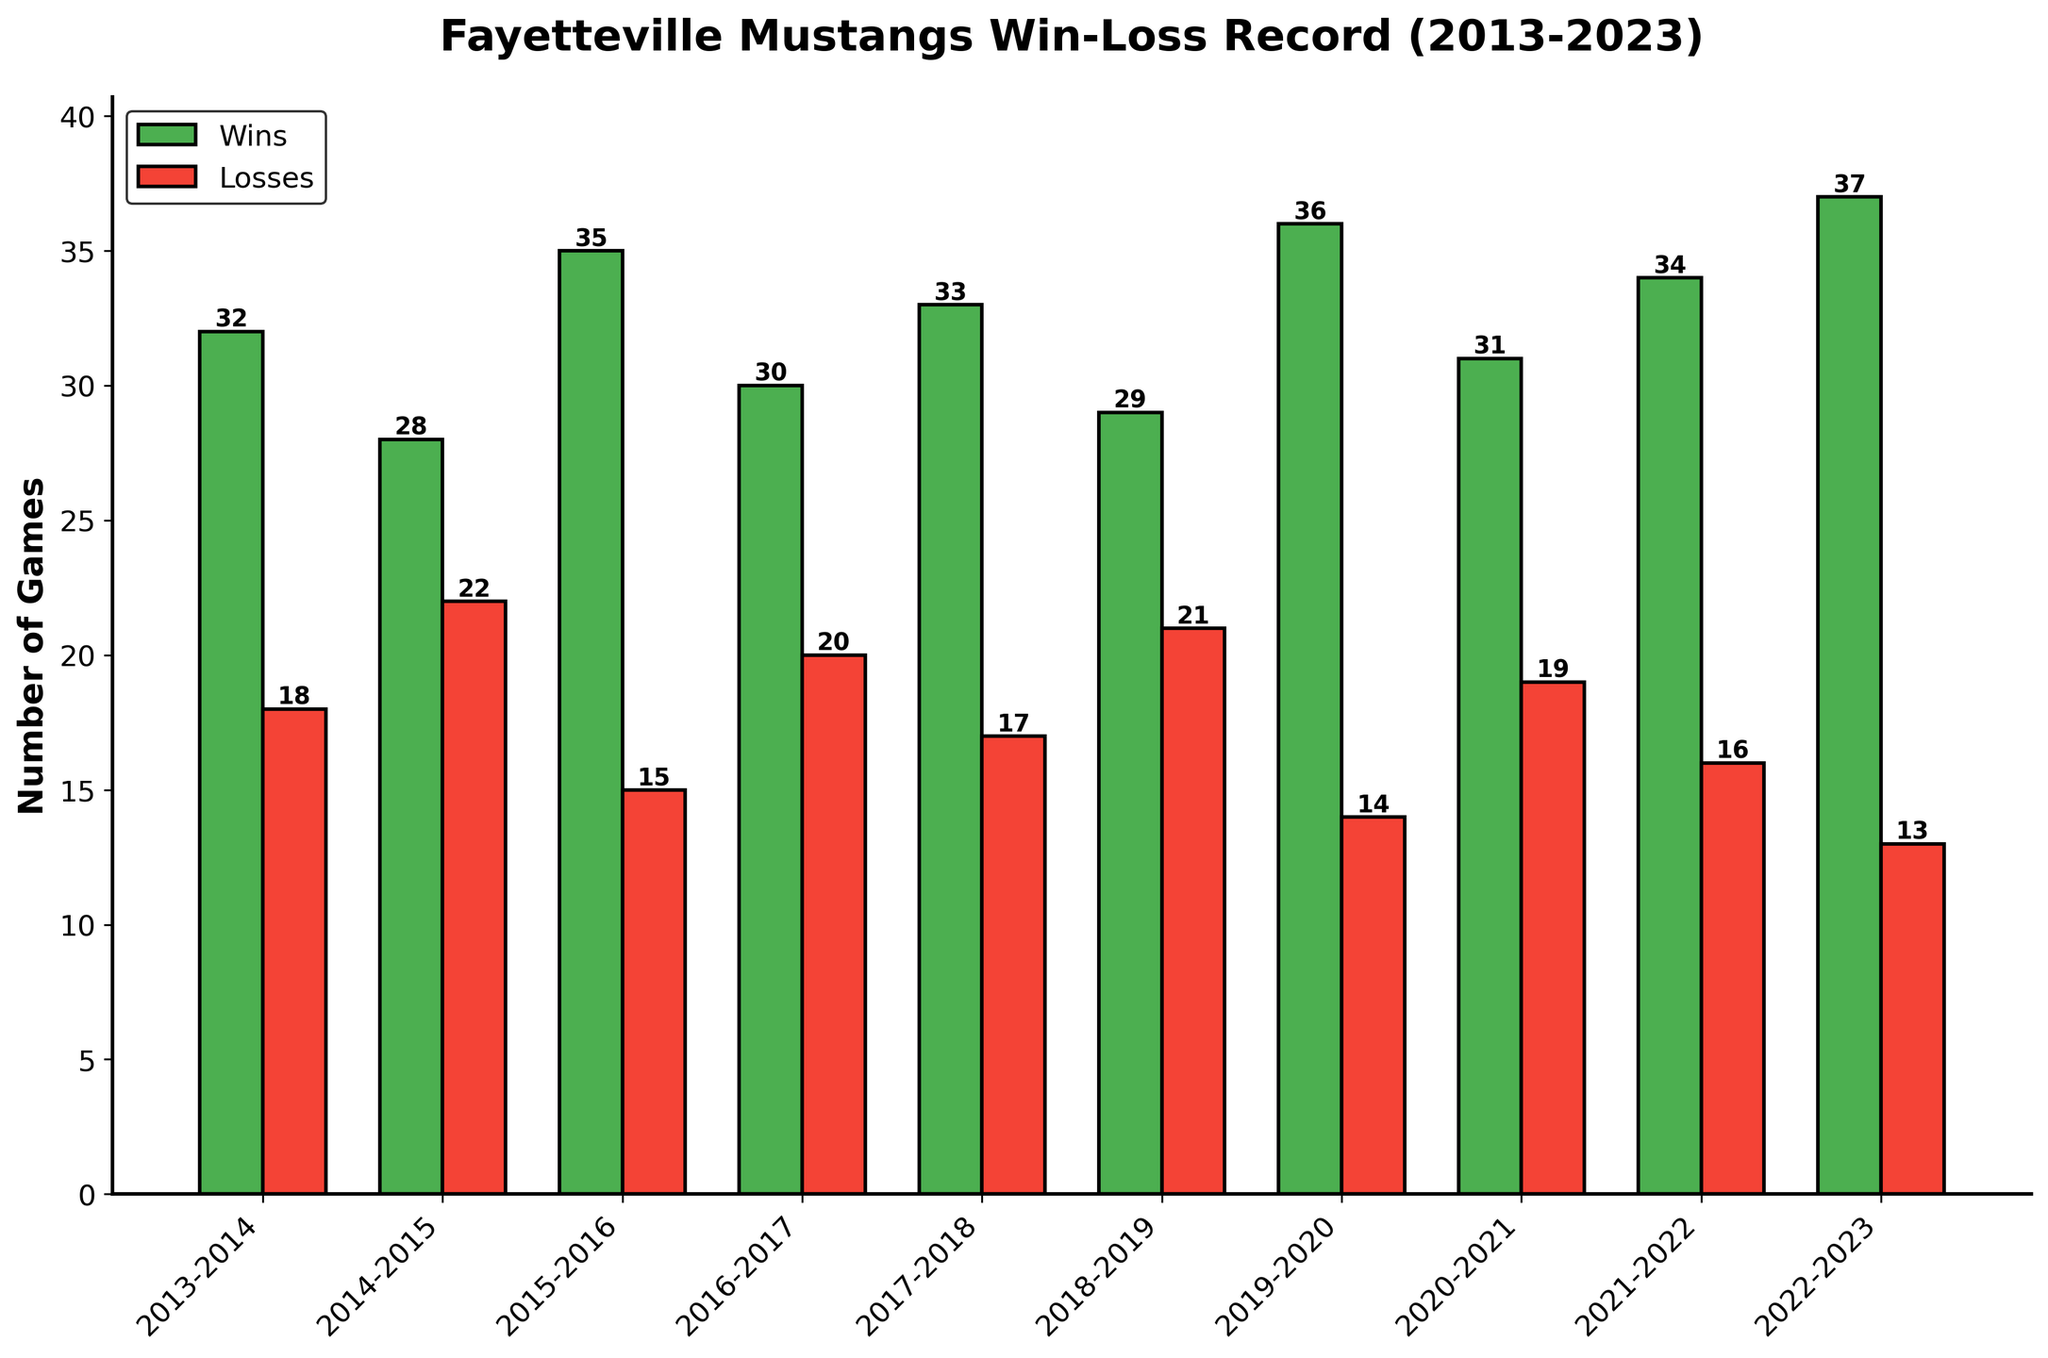Which season had the highest number of wins? First, observe which bar representing wins is tallest. The tallest bar corresponds to the 2022-2023 season with 37 wins.
Answer: 2022-2023 Which season had the lowest number of wins? Look for the shortest bar representing wins. The shortest win bar belongs to the 2014-2015 season with 28 wins.
Answer: 2014-2015 How many more wins did the 2019-2020 season have compared to the 2014-2015 season? Subtract the wins of the 2014-2015 season (28) from the wins of the 2019-2020 season (36). \(36 - 28 = 8\).
Answer: 8 What is the difference between the highest and lowest number of losses in any season? Identify the highest (22 in 2014-2015) and the lowest (13 in 2022-2023) values for losses. Subtract the lowest from the highest: \(22 - 13 = 9\).
Answer: 9 Which season had an equal number of wins and losses, if any? Scan visually to see if any year has bars of equal height for wins and losses. No season has equal win and loss bars.
Answer: None Which seasons had more than 30 wins? Identify bars higher than 30 in the win column. These seasons are 2013-2014 (32), 2015-2016 (35), 2016-2017 (30), 2017-2018 (33), 2019-2020 (36), 2020-2021 (31), 2021-2022 (34), and 2022-2023 (37).
Answer: 8 seasons What is the average number of losses per season? Add all the losses: \(18 + 22 + 15 + 20 + 17 + 21 + 14 + 19 + 16 + 13 = 175\). Divide by the number of seasons (10): \(175/10 = 17.5\).
Answer: 17.5 Which two consecutive seasons showed the largest improvement in the number of wins? Calculate differences between consecutive seasons' wins: 
\(28-32=-4\), 
\(35-28=7\), 
\(30-35=-5\), 
\(33-30=3\), 
\(29-33=-4\), 
\(36-29=7\),
\(31-36=-5\),
\(34-31=3\),
\(37-34=3\).
The largest positive change is from 2014-2015 to 2015-2016, and from 2018-2019 to 2019-2020, both with an improvement of 7.
Answer: 2014-2015 to 2015-2016, 2018-2019 to 2019-2020 How many seasons had fewer losses than wins? Count the seasons where the win bar is taller than the loss bar. All seasons: 2013-2023 (10).
Answer: 10 